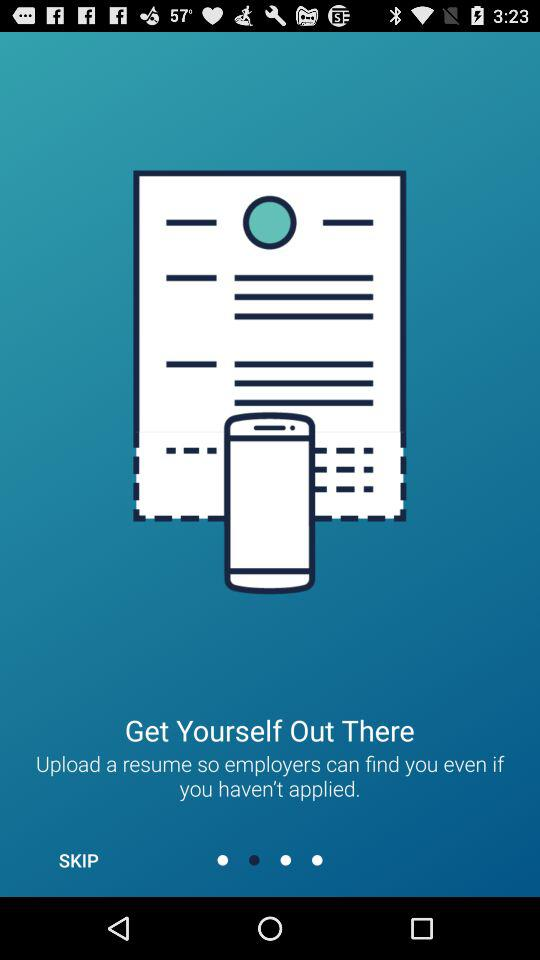What is the name of the application?
When the provided information is insufficient, respond with <no answer>. <no answer> 